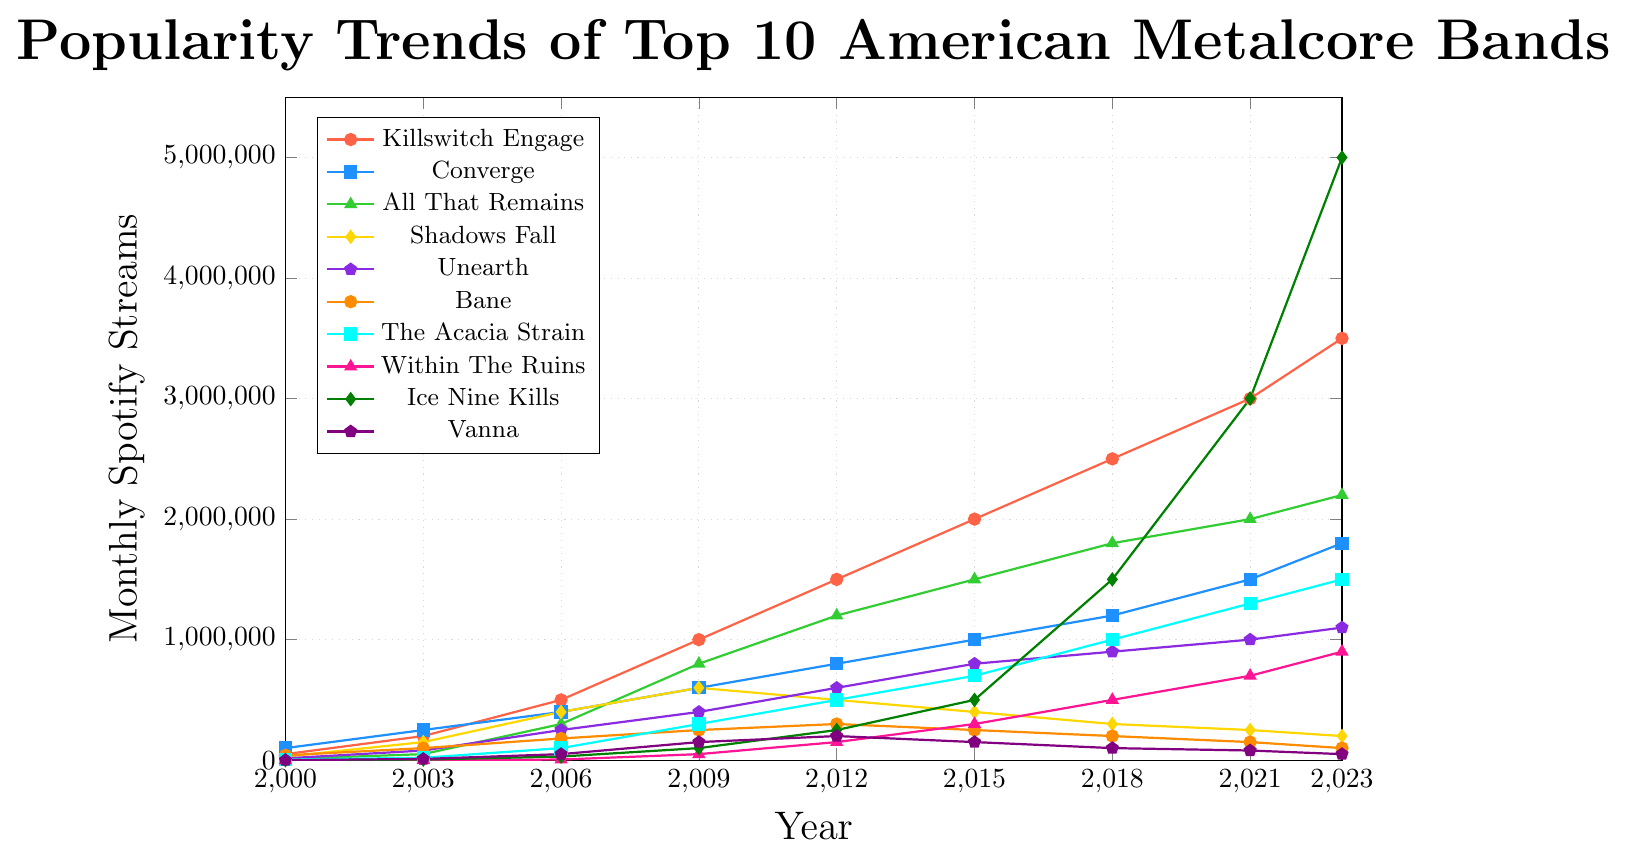What's the trend in monthly Spotify streams for Killswitch Engage between 2000 and 2023? The trend for Killswitch Engage shows a clear increase in monthly Spotify streams from 50,000 in 2000 to 3.5 million in 2023. Each data point over the years indicates a steady rise.
Answer: Increasing Which band had the highest monthly Spotify streams in 2023? By looking at the highest peak in 2023, Ice Nine Kills reaches 5 million monthly Spotify streams, which is the highest among all bands.
Answer: Ice Nine Kills How do the monthly streams of Converge in 2003 compare to Killswitch Engage in the same year? In 2003, Converge had 250,000 monthly streams, while Killswitch Engage had 200,000. Therefore, Converge had more monthly streams than Killswitch Engage in 2003.
Answer: Converge had more What is the difference between the monthly Spotify streams of Shadows Fall in 2009 and 2023? Shadows Fall had 600,000 monthly streams in 2009 and 200,000 in 2023. The difference is calculated as 600,000 - 200,000 = 400,000.
Answer: 400,000 Which band showed the most dramatic increase in popularity from 2000 to 2023? Analyzing the slopes, Ice Nine Kills had an increase from 0 in 2000 to 5 million in 2023, the most dramatic increase among all bands.
Answer: Ice Nine Kills Between 2015 and 2023, which band had a decreasing trend in monthly Spotify streams? Shadows Fall shows a decreasing trend from 400,000 monthly streams in 2015 down to 200,000 in 2023.
Answer: Shadows Fall What is the total monthly Spotify streams for Bane in all recorded years? Summing up the values for Bane: 40,000 (2000) + 100,000 (2003) + 180,000 (2006) + 250,000 (2009) + 300,000 (2012) + 250,000 (2015) + 200,000 (2018) + 150,000 (2021) + 100,000 (2023) = 1,570,000.
Answer: 1,570,000 How does the peak popularity of Unearth in 2023 compare visually with the band's popularity in 2006? Unearth's streams in 2023 are higher (1.1 million) compared to 2006 (250,000), visibly indicated by the higher data point in color.
Answer: Peak in 2023 higher Calculate the average monthly streams for Vanna over all recorded years. Sum all the values for Vanna: 0 (2000) + 10,000 (2003) + 50,000 (2006) + 150,000 (2009) + 200,000 (2012) + 150,000 (2015) + 100,000 (2018) + 80,000 (2021) + 50,000 (2023) = 790,000. Average is 790,000 / 9 ≈ 87,778.
Answer: 87,778 In which year did All That Remains surpass both Killswitch Engage and Converge in monthly Spotify streams? In 2009, All That Remains had 800,000 monthly streams, while Killswitch Engage had 1 million and Converge had 600,000. All That Remains did not surpass both bands in any given year.
Answer: None 